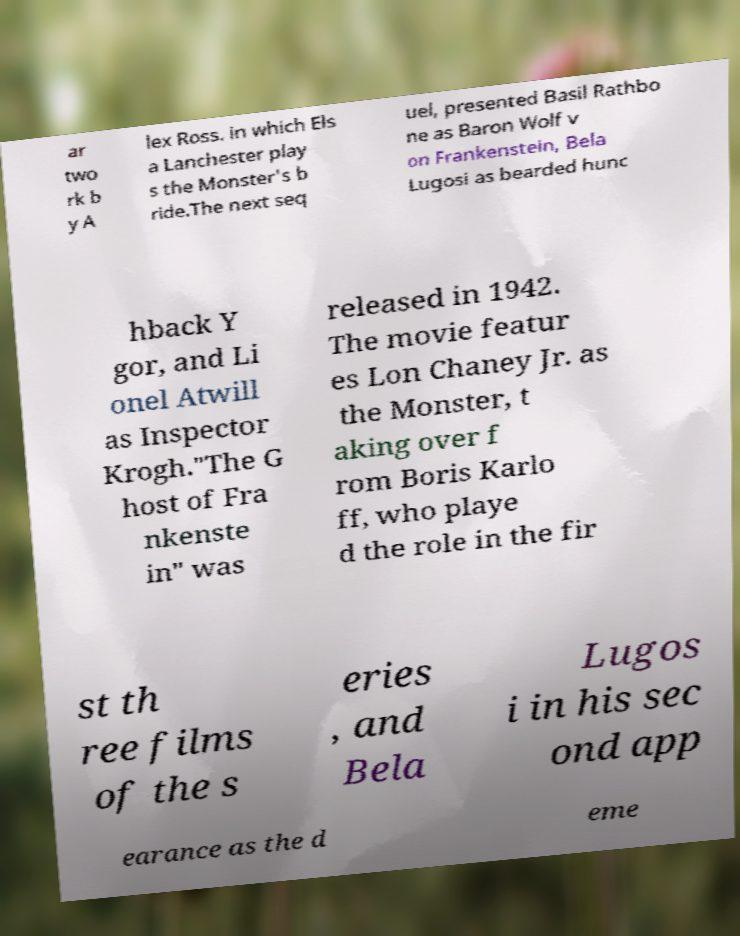What messages or text are displayed in this image? I need them in a readable, typed format. ar two rk b y A lex Ross. in which Els a Lanchester play s the Monster's b ride.The next seq uel, presented Basil Rathbo ne as Baron Wolf v on Frankenstein, Bela Lugosi as bearded hunc hback Y gor, and Li onel Atwill as Inspector Krogh."The G host of Fra nkenste in" was released in 1942. The movie featur es Lon Chaney Jr. as the Monster, t aking over f rom Boris Karlo ff, who playe d the role in the fir st th ree films of the s eries , and Bela Lugos i in his sec ond app earance as the d eme 